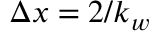Convert formula to latex. <formula><loc_0><loc_0><loc_500><loc_500>\Delta x = 2 / k _ { w }</formula> 